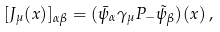Convert formula to latex. <formula><loc_0><loc_0><loc_500><loc_500>[ J _ { \mu } ( x ) ] _ { \alpha \beta } = ( \bar { \psi } _ { \alpha } \gamma _ { \mu } P _ { - } \tilde { \psi } _ { \beta } ) ( x ) \, ,</formula> 